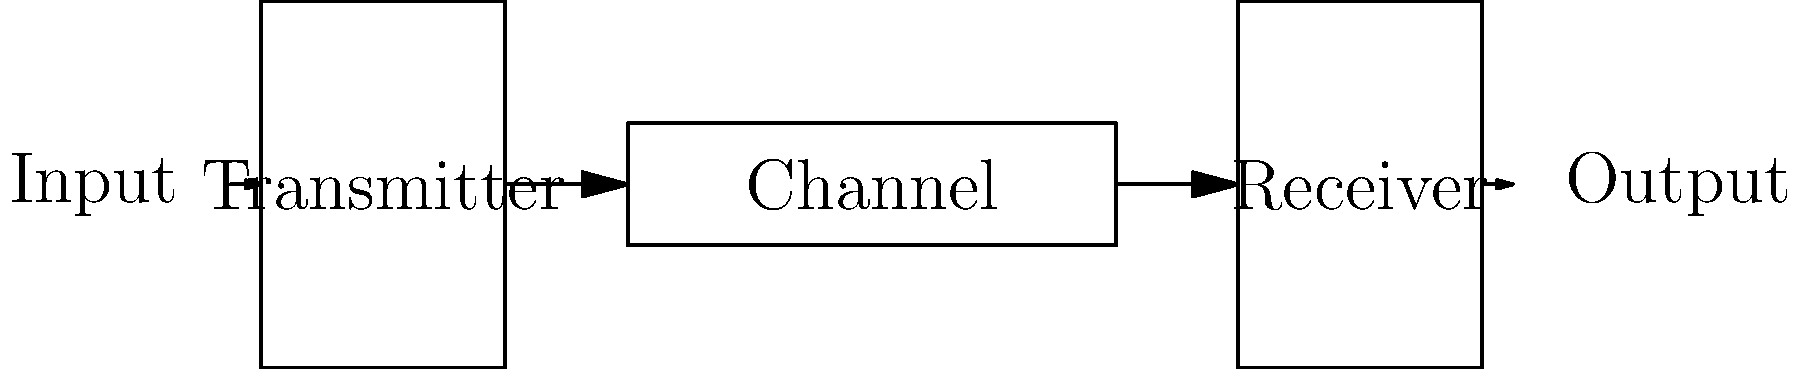In the context of media representation of women in communication systems, analyze the block diagram shown. How might the components of this basic communication system metaphorically represent the challenges faced by women's voices in traditional media channels? To answer this question, let's break down the components of the communication system and relate them to the challenges faced by women's voices in traditional media:

1. Input: This represents the original message or content created by women.

2. Transmitter: This component can be seen as the initial media platform or channel where women's stories are first shared. It could face issues such as:
   - Limited access for women to prominent media positions
   - Bias in story selection favoring male perspectives

3. Channel: This represents the medium through which the message travels. In media terms, this could be:
   - Mainstream media outlets
   - Social media platforms
   - Publishing houses
Challenges here might include:
   - Noise or distortion of the original message
   - Gatekeeping by predominantly male-led institutions
   - Algorithms that may not prioritize women's content

4. Receiver: This component represents the audience or consumers of media. Challenges here could include:
   - Preconceived notions or biases affecting interpretation
   - Lack of diverse perspectives in the receiving audience

5. Output: The final message as received by the audience, which may differ from the original input due to the challenges faced in each stage.

The overall system highlights how women's voices can be altered, diminished, or lost as they pass through traditional media channels, emphasizing the need for more equitable representation and transmission of women's stories and perspectives.
Answer: Transmitter: limited access/bias; Channel: gatekeeping/algorithms; Receiver: audience biases; collectively altering women's voices in media. 